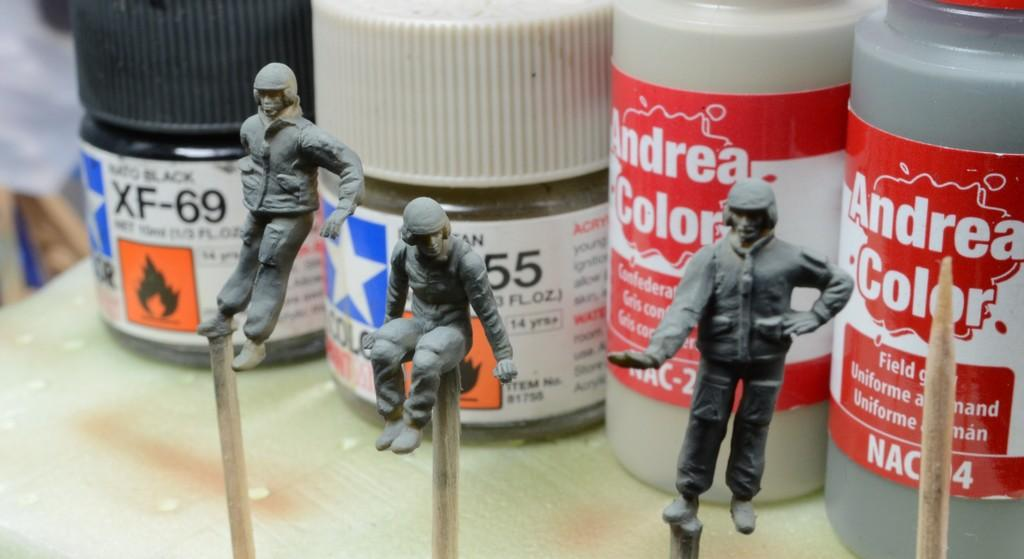What can be seen in the image that resembles tall, vertical structures? There are poles in the image. What type of artistic figures are present in the image? There are statues in the image. What is the location of the objects that are elevated above the ground? The objects are on a platform in the image. What type of space vehicle can be seen in the image? There is no space vehicle present in the image. Can you describe the bee that is buzzing around the statues in the image? There is no bee present in the image; it only features poles, statues, and objects on a platform. 